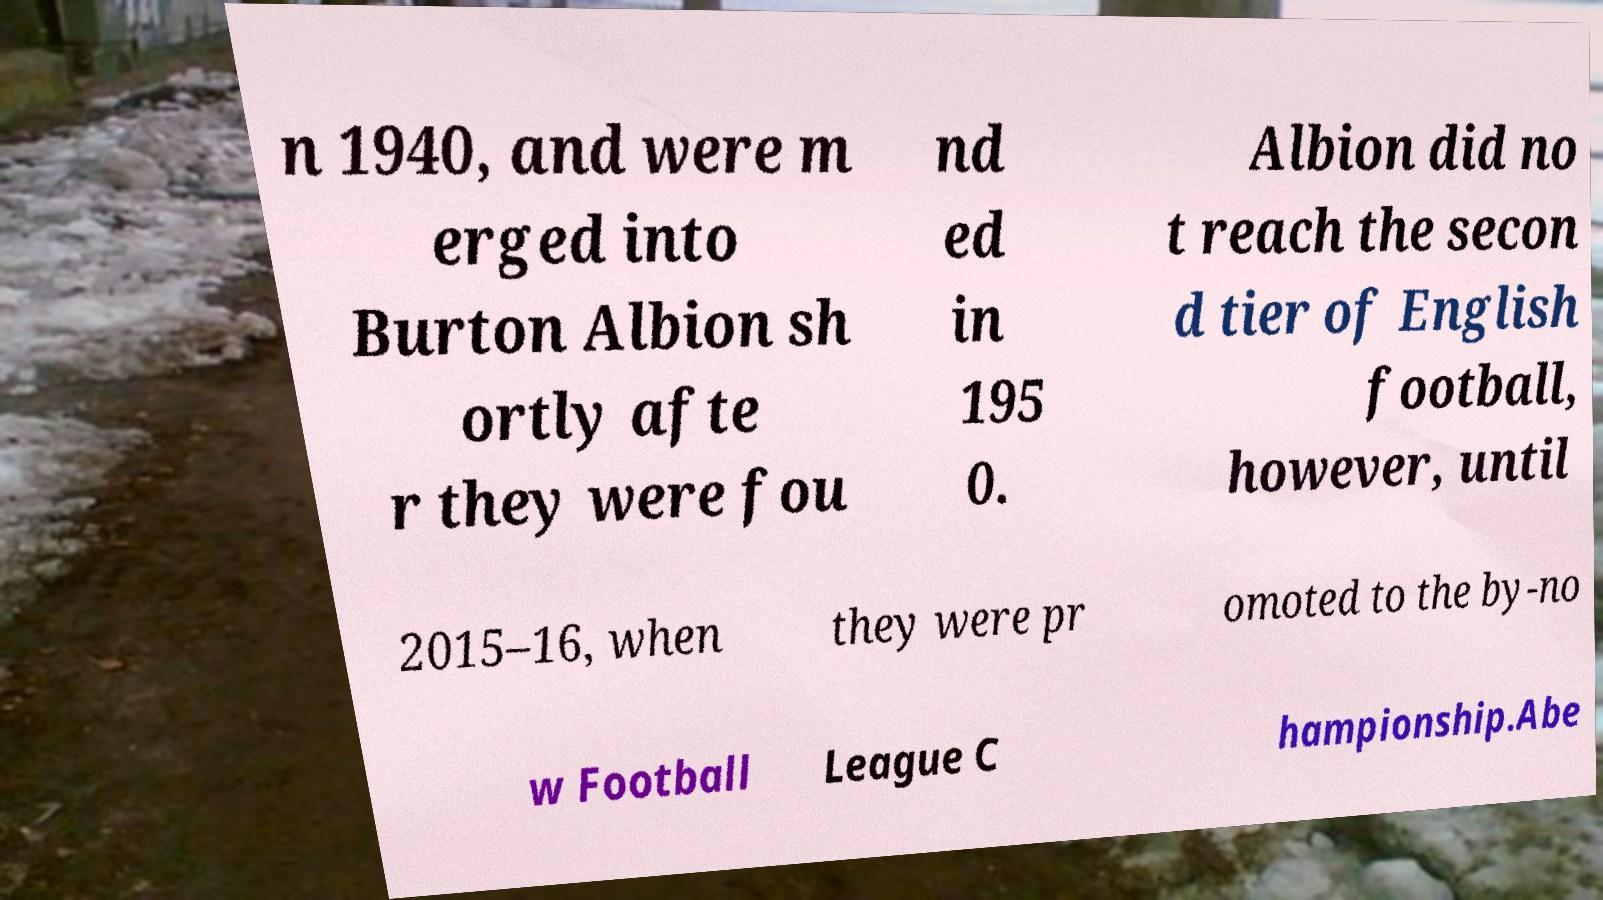Can you read and provide the text displayed in the image?This photo seems to have some interesting text. Can you extract and type it out for me? n 1940, and were m erged into Burton Albion sh ortly afte r they were fou nd ed in 195 0. Albion did no t reach the secon d tier of English football, however, until 2015–16, when they were pr omoted to the by-no w Football League C hampionship.Abe 